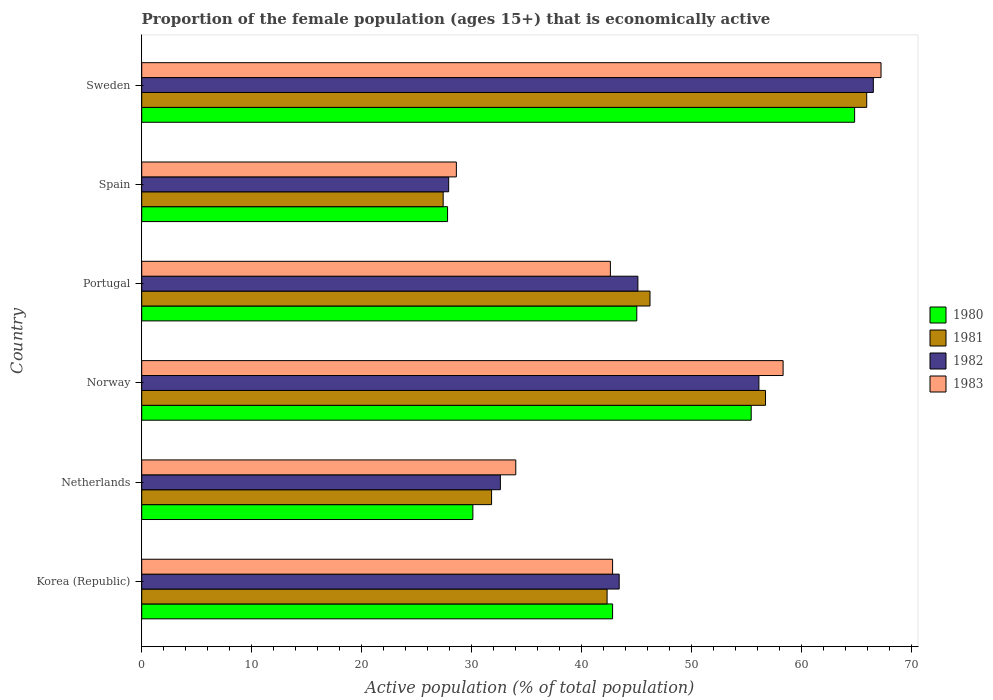Are the number of bars per tick equal to the number of legend labels?
Offer a terse response. Yes. Are the number of bars on each tick of the Y-axis equal?
Offer a terse response. Yes. What is the label of the 3rd group of bars from the top?
Offer a very short reply. Portugal. In how many cases, is the number of bars for a given country not equal to the number of legend labels?
Give a very brief answer. 0. What is the proportion of the female population that is economically active in 1982 in Sweden?
Keep it short and to the point. 66.5. Across all countries, what is the maximum proportion of the female population that is economically active in 1983?
Keep it short and to the point. 67.2. Across all countries, what is the minimum proportion of the female population that is economically active in 1982?
Offer a very short reply. 27.9. In which country was the proportion of the female population that is economically active in 1981 minimum?
Give a very brief answer. Spain. What is the total proportion of the female population that is economically active in 1980 in the graph?
Provide a short and direct response. 265.9. What is the difference between the proportion of the female population that is economically active in 1983 in Portugal and that in Spain?
Offer a very short reply. 14. What is the difference between the proportion of the female population that is economically active in 1981 in Portugal and the proportion of the female population that is economically active in 1980 in Netherlands?
Offer a terse response. 16.1. What is the average proportion of the female population that is economically active in 1983 per country?
Give a very brief answer. 45.58. What is the difference between the proportion of the female population that is economically active in 1982 and proportion of the female population that is economically active in 1983 in Netherlands?
Provide a short and direct response. -1.4. In how many countries, is the proportion of the female population that is economically active in 1982 greater than 52 %?
Ensure brevity in your answer.  2. What is the ratio of the proportion of the female population that is economically active in 1980 in Korea (Republic) to that in Spain?
Provide a short and direct response. 1.54. Is the proportion of the female population that is economically active in 1980 in Spain less than that in Sweden?
Make the answer very short. Yes. What is the difference between the highest and the second highest proportion of the female population that is economically active in 1980?
Provide a succinct answer. 9.4. What is the difference between the highest and the lowest proportion of the female population that is economically active in 1980?
Keep it short and to the point. 37. In how many countries, is the proportion of the female population that is economically active in 1982 greater than the average proportion of the female population that is economically active in 1982 taken over all countries?
Keep it short and to the point. 2. What does the 3rd bar from the bottom in Korea (Republic) represents?
Give a very brief answer. 1982. Is it the case that in every country, the sum of the proportion of the female population that is economically active in 1983 and proportion of the female population that is economically active in 1982 is greater than the proportion of the female population that is economically active in 1980?
Offer a very short reply. Yes. Are all the bars in the graph horizontal?
Make the answer very short. Yes. Where does the legend appear in the graph?
Your answer should be compact. Center right. How are the legend labels stacked?
Make the answer very short. Vertical. What is the title of the graph?
Ensure brevity in your answer.  Proportion of the female population (ages 15+) that is economically active. What is the label or title of the X-axis?
Your response must be concise. Active population (% of total population). What is the label or title of the Y-axis?
Ensure brevity in your answer.  Country. What is the Active population (% of total population) in 1980 in Korea (Republic)?
Provide a succinct answer. 42.8. What is the Active population (% of total population) in 1981 in Korea (Republic)?
Give a very brief answer. 42.3. What is the Active population (% of total population) in 1982 in Korea (Republic)?
Make the answer very short. 43.4. What is the Active population (% of total population) in 1983 in Korea (Republic)?
Provide a short and direct response. 42.8. What is the Active population (% of total population) of 1980 in Netherlands?
Give a very brief answer. 30.1. What is the Active population (% of total population) of 1981 in Netherlands?
Offer a very short reply. 31.8. What is the Active population (% of total population) of 1982 in Netherlands?
Keep it short and to the point. 32.6. What is the Active population (% of total population) in 1983 in Netherlands?
Your answer should be very brief. 34. What is the Active population (% of total population) in 1980 in Norway?
Your response must be concise. 55.4. What is the Active population (% of total population) of 1981 in Norway?
Give a very brief answer. 56.7. What is the Active population (% of total population) in 1982 in Norway?
Keep it short and to the point. 56.1. What is the Active population (% of total population) of 1983 in Norway?
Offer a very short reply. 58.3. What is the Active population (% of total population) in 1980 in Portugal?
Your answer should be compact. 45. What is the Active population (% of total population) of 1981 in Portugal?
Keep it short and to the point. 46.2. What is the Active population (% of total population) in 1982 in Portugal?
Your answer should be compact. 45.1. What is the Active population (% of total population) in 1983 in Portugal?
Give a very brief answer. 42.6. What is the Active population (% of total population) in 1980 in Spain?
Offer a terse response. 27.8. What is the Active population (% of total population) in 1981 in Spain?
Your response must be concise. 27.4. What is the Active population (% of total population) of 1982 in Spain?
Offer a very short reply. 27.9. What is the Active population (% of total population) of 1983 in Spain?
Your response must be concise. 28.6. What is the Active population (% of total population) of 1980 in Sweden?
Your answer should be very brief. 64.8. What is the Active population (% of total population) of 1981 in Sweden?
Your answer should be compact. 65.9. What is the Active population (% of total population) of 1982 in Sweden?
Make the answer very short. 66.5. What is the Active population (% of total population) of 1983 in Sweden?
Ensure brevity in your answer.  67.2. Across all countries, what is the maximum Active population (% of total population) in 1980?
Keep it short and to the point. 64.8. Across all countries, what is the maximum Active population (% of total population) of 1981?
Keep it short and to the point. 65.9. Across all countries, what is the maximum Active population (% of total population) of 1982?
Your answer should be compact. 66.5. Across all countries, what is the maximum Active population (% of total population) of 1983?
Offer a very short reply. 67.2. Across all countries, what is the minimum Active population (% of total population) in 1980?
Your answer should be very brief. 27.8. Across all countries, what is the minimum Active population (% of total population) in 1981?
Make the answer very short. 27.4. Across all countries, what is the minimum Active population (% of total population) in 1982?
Keep it short and to the point. 27.9. Across all countries, what is the minimum Active population (% of total population) of 1983?
Keep it short and to the point. 28.6. What is the total Active population (% of total population) of 1980 in the graph?
Your answer should be very brief. 265.9. What is the total Active population (% of total population) of 1981 in the graph?
Ensure brevity in your answer.  270.3. What is the total Active population (% of total population) of 1982 in the graph?
Offer a very short reply. 271.6. What is the total Active population (% of total population) in 1983 in the graph?
Your response must be concise. 273.5. What is the difference between the Active population (% of total population) of 1980 in Korea (Republic) and that in Netherlands?
Offer a terse response. 12.7. What is the difference between the Active population (% of total population) of 1981 in Korea (Republic) and that in Netherlands?
Offer a terse response. 10.5. What is the difference between the Active population (% of total population) of 1983 in Korea (Republic) and that in Netherlands?
Ensure brevity in your answer.  8.8. What is the difference between the Active population (% of total population) of 1980 in Korea (Republic) and that in Norway?
Ensure brevity in your answer.  -12.6. What is the difference between the Active population (% of total population) in 1981 in Korea (Republic) and that in Norway?
Give a very brief answer. -14.4. What is the difference between the Active population (% of total population) in 1982 in Korea (Republic) and that in Norway?
Provide a short and direct response. -12.7. What is the difference between the Active population (% of total population) in 1983 in Korea (Republic) and that in Norway?
Provide a short and direct response. -15.5. What is the difference between the Active population (% of total population) of 1980 in Korea (Republic) and that in Portugal?
Offer a terse response. -2.2. What is the difference between the Active population (% of total population) in 1982 in Korea (Republic) and that in Portugal?
Offer a terse response. -1.7. What is the difference between the Active population (% of total population) of 1981 in Korea (Republic) and that in Sweden?
Ensure brevity in your answer.  -23.6. What is the difference between the Active population (% of total population) in 1982 in Korea (Republic) and that in Sweden?
Offer a very short reply. -23.1. What is the difference between the Active population (% of total population) of 1983 in Korea (Republic) and that in Sweden?
Your response must be concise. -24.4. What is the difference between the Active population (% of total population) of 1980 in Netherlands and that in Norway?
Provide a short and direct response. -25.3. What is the difference between the Active population (% of total population) in 1981 in Netherlands and that in Norway?
Your answer should be very brief. -24.9. What is the difference between the Active population (% of total population) of 1982 in Netherlands and that in Norway?
Make the answer very short. -23.5. What is the difference between the Active population (% of total population) in 1983 in Netherlands and that in Norway?
Provide a succinct answer. -24.3. What is the difference between the Active population (% of total population) of 1980 in Netherlands and that in Portugal?
Your response must be concise. -14.9. What is the difference between the Active population (% of total population) of 1981 in Netherlands and that in Portugal?
Provide a short and direct response. -14.4. What is the difference between the Active population (% of total population) in 1983 in Netherlands and that in Spain?
Your answer should be compact. 5.4. What is the difference between the Active population (% of total population) of 1980 in Netherlands and that in Sweden?
Offer a terse response. -34.7. What is the difference between the Active population (% of total population) of 1981 in Netherlands and that in Sweden?
Provide a short and direct response. -34.1. What is the difference between the Active population (% of total population) of 1982 in Netherlands and that in Sweden?
Make the answer very short. -33.9. What is the difference between the Active population (% of total population) in 1983 in Netherlands and that in Sweden?
Ensure brevity in your answer.  -33.2. What is the difference between the Active population (% of total population) in 1981 in Norway and that in Portugal?
Offer a terse response. 10.5. What is the difference between the Active population (% of total population) in 1982 in Norway and that in Portugal?
Provide a succinct answer. 11. What is the difference between the Active population (% of total population) in 1980 in Norway and that in Spain?
Your answer should be compact. 27.6. What is the difference between the Active population (% of total population) of 1981 in Norway and that in Spain?
Your response must be concise. 29.3. What is the difference between the Active population (% of total population) of 1982 in Norway and that in Spain?
Your response must be concise. 28.2. What is the difference between the Active population (% of total population) of 1983 in Norway and that in Spain?
Make the answer very short. 29.7. What is the difference between the Active population (% of total population) of 1983 in Norway and that in Sweden?
Keep it short and to the point. -8.9. What is the difference between the Active population (% of total population) in 1980 in Portugal and that in Spain?
Your answer should be very brief. 17.2. What is the difference between the Active population (% of total population) of 1981 in Portugal and that in Spain?
Your answer should be compact. 18.8. What is the difference between the Active population (% of total population) of 1982 in Portugal and that in Spain?
Offer a very short reply. 17.2. What is the difference between the Active population (% of total population) of 1980 in Portugal and that in Sweden?
Provide a short and direct response. -19.8. What is the difference between the Active population (% of total population) in 1981 in Portugal and that in Sweden?
Keep it short and to the point. -19.7. What is the difference between the Active population (% of total population) of 1982 in Portugal and that in Sweden?
Ensure brevity in your answer.  -21.4. What is the difference between the Active population (% of total population) of 1983 in Portugal and that in Sweden?
Your answer should be very brief. -24.6. What is the difference between the Active population (% of total population) of 1980 in Spain and that in Sweden?
Your answer should be compact. -37. What is the difference between the Active population (% of total population) in 1981 in Spain and that in Sweden?
Provide a succinct answer. -38.5. What is the difference between the Active population (% of total population) of 1982 in Spain and that in Sweden?
Offer a very short reply. -38.6. What is the difference between the Active population (% of total population) in 1983 in Spain and that in Sweden?
Give a very brief answer. -38.6. What is the difference between the Active population (% of total population) in 1980 in Korea (Republic) and the Active population (% of total population) in 1981 in Netherlands?
Provide a short and direct response. 11. What is the difference between the Active population (% of total population) of 1980 in Korea (Republic) and the Active population (% of total population) of 1983 in Netherlands?
Give a very brief answer. 8.8. What is the difference between the Active population (% of total population) in 1981 in Korea (Republic) and the Active population (% of total population) in 1982 in Netherlands?
Provide a succinct answer. 9.7. What is the difference between the Active population (% of total population) in 1981 in Korea (Republic) and the Active population (% of total population) in 1983 in Netherlands?
Keep it short and to the point. 8.3. What is the difference between the Active population (% of total population) in 1982 in Korea (Republic) and the Active population (% of total population) in 1983 in Netherlands?
Give a very brief answer. 9.4. What is the difference between the Active population (% of total population) of 1980 in Korea (Republic) and the Active population (% of total population) of 1981 in Norway?
Your answer should be very brief. -13.9. What is the difference between the Active population (% of total population) in 1980 in Korea (Republic) and the Active population (% of total population) in 1982 in Norway?
Your answer should be compact. -13.3. What is the difference between the Active population (% of total population) in 1980 in Korea (Republic) and the Active population (% of total population) in 1983 in Norway?
Keep it short and to the point. -15.5. What is the difference between the Active population (% of total population) in 1981 in Korea (Republic) and the Active population (% of total population) in 1982 in Norway?
Provide a short and direct response. -13.8. What is the difference between the Active population (% of total population) in 1981 in Korea (Republic) and the Active population (% of total population) in 1983 in Norway?
Give a very brief answer. -16. What is the difference between the Active population (% of total population) in 1982 in Korea (Republic) and the Active population (% of total population) in 1983 in Norway?
Provide a succinct answer. -14.9. What is the difference between the Active population (% of total population) in 1980 in Korea (Republic) and the Active population (% of total population) in 1981 in Portugal?
Provide a short and direct response. -3.4. What is the difference between the Active population (% of total population) in 1980 in Korea (Republic) and the Active population (% of total population) in 1983 in Portugal?
Your answer should be very brief. 0.2. What is the difference between the Active population (% of total population) in 1982 in Korea (Republic) and the Active population (% of total population) in 1983 in Portugal?
Make the answer very short. 0.8. What is the difference between the Active population (% of total population) of 1980 in Korea (Republic) and the Active population (% of total population) of 1981 in Spain?
Your answer should be compact. 15.4. What is the difference between the Active population (% of total population) in 1980 in Korea (Republic) and the Active population (% of total population) in 1982 in Spain?
Offer a terse response. 14.9. What is the difference between the Active population (% of total population) of 1980 in Korea (Republic) and the Active population (% of total population) of 1983 in Spain?
Offer a very short reply. 14.2. What is the difference between the Active population (% of total population) of 1981 in Korea (Republic) and the Active population (% of total population) of 1983 in Spain?
Keep it short and to the point. 13.7. What is the difference between the Active population (% of total population) of 1980 in Korea (Republic) and the Active population (% of total population) of 1981 in Sweden?
Offer a very short reply. -23.1. What is the difference between the Active population (% of total population) in 1980 in Korea (Republic) and the Active population (% of total population) in 1982 in Sweden?
Give a very brief answer. -23.7. What is the difference between the Active population (% of total population) in 1980 in Korea (Republic) and the Active population (% of total population) in 1983 in Sweden?
Keep it short and to the point. -24.4. What is the difference between the Active population (% of total population) in 1981 in Korea (Republic) and the Active population (% of total population) in 1982 in Sweden?
Offer a terse response. -24.2. What is the difference between the Active population (% of total population) of 1981 in Korea (Republic) and the Active population (% of total population) of 1983 in Sweden?
Keep it short and to the point. -24.9. What is the difference between the Active population (% of total population) of 1982 in Korea (Republic) and the Active population (% of total population) of 1983 in Sweden?
Make the answer very short. -23.8. What is the difference between the Active population (% of total population) of 1980 in Netherlands and the Active population (% of total population) of 1981 in Norway?
Ensure brevity in your answer.  -26.6. What is the difference between the Active population (% of total population) in 1980 in Netherlands and the Active population (% of total population) in 1982 in Norway?
Keep it short and to the point. -26. What is the difference between the Active population (% of total population) in 1980 in Netherlands and the Active population (% of total population) in 1983 in Norway?
Your response must be concise. -28.2. What is the difference between the Active population (% of total population) in 1981 in Netherlands and the Active population (% of total population) in 1982 in Norway?
Offer a terse response. -24.3. What is the difference between the Active population (% of total population) of 1981 in Netherlands and the Active population (% of total population) of 1983 in Norway?
Your answer should be compact. -26.5. What is the difference between the Active population (% of total population) in 1982 in Netherlands and the Active population (% of total population) in 1983 in Norway?
Keep it short and to the point. -25.7. What is the difference between the Active population (% of total population) in 1980 in Netherlands and the Active population (% of total population) in 1981 in Portugal?
Your answer should be very brief. -16.1. What is the difference between the Active population (% of total population) of 1982 in Netherlands and the Active population (% of total population) of 1983 in Portugal?
Offer a very short reply. -10. What is the difference between the Active population (% of total population) of 1980 in Netherlands and the Active population (% of total population) of 1981 in Spain?
Ensure brevity in your answer.  2.7. What is the difference between the Active population (% of total population) of 1980 in Netherlands and the Active population (% of total population) of 1982 in Spain?
Offer a very short reply. 2.2. What is the difference between the Active population (% of total population) of 1980 in Netherlands and the Active population (% of total population) of 1983 in Spain?
Your response must be concise. 1.5. What is the difference between the Active population (% of total population) of 1981 in Netherlands and the Active population (% of total population) of 1982 in Spain?
Ensure brevity in your answer.  3.9. What is the difference between the Active population (% of total population) of 1981 in Netherlands and the Active population (% of total population) of 1983 in Spain?
Make the answer very short. 3.2. What is the difference between the Active population (% of total population) in 1980 in Netherlands and the Active population (% of total population) in 1981 in Sweden?
Provide a short and direct response. -35.8. What is the difference between the Active population (% of total population) of 1980 in Netherlands and the Active population (% of total population) of 1982 in Sweden?
Offer a terse response. -36.4. What is the difference between the Active population (% of total population) of 1980 in Netherlands and the Active population (% of total population) of 1983 in Sweden?
Offer a very short reply. -37.1. What is the difference between the Active population (% of total population) in 1981 in Netherlands and the Active population (% of total population) in 1982 in Sweden?
Your answer should be compact. -34.7. What is the difference between the Active population (% of total population) in 1981 in Netherlands and the Active population (% of total population) in 1983 in Sweden?
Keep it short and to the point. -35.4. What is the difference between the Active population (% of total population) of 1982 in Netherlands and the Active population (% of total population) of 1983 in Sweden?
Provide a short and direct response. -34.6. What is the difference between the Active population (% of total population) of 1980 in Norway and the Active population (% of total population) of 1981 in Portugal?
Offer a very short reply. 9.2. What is the difference between the Active population (% of total population) of 1980 in Norway and the Active population (% of total population) of 1983 in Portugal?
Offer a very short reply. 12.8. What is the difference between the Active population (% of total population) in 1980 in Norway and the Active population (% of total population) in 1983 in Spain?
Make the answer very short. 26.8. What is the difference between the Active population (% of total population) of 1981 in Norway and the Active population (% of total population) of 1982 in Spain?
Provide a succinct answer. 28.8. What is the difference between the Active population (% of total population) in 1981 in Norway and the Active population (% of total population) in 1983 in Spain?
Your response must be concise. 28.1. What is the difference between the Active population (% of total population) of 1980 in Norway and the Active population (% of total population) of 1983 in Sweden?
Make the answer very short. -11.8. What is the difference between the Active population (% of total population) in 1981 in Norway and the Active population (% of total population) in 1982 in Sweden?
Your answer should be very brief. -9.8. What is the difference between the Active population (% of total population) in 1980 in Portugal and the Active population (% of total population) in 1981 in Spain?
Your response must be concise. 17.6. What is the difference between the Active population (% of total population) in 1981 in Portugal and the Active population (% of total population) in 1982 in Spain?
Provide a short and direct response. 18.3. What is the difference between the Active population (% of total population) of 1982 in Portugal and the Active population (% of total population) of 1983 in Spain?
Your answer should be very brief. 16.5. What is the difference between the Active population (% of total population) in 1980 in Portugal and the Active population (% of total population) in 1981 in Sweden?
Keep it short and to the point. -20.9. What is the difference between the Active population (% of total population) in 1980 in Portugal and the Active population (% of total population) in 1982 in Sweden?
Give a very brief answer. -21.5. What is the difference between the Active population (% of total population) in 1980 in Portugal and the Active population (% of total population) in 1983 in Sweden?
Ensure brevity in your answer.  -22.2. What is the difference between the Active population (% of total population) of 1981 in Portugal and the Active population (% of total population) of 1982 in Sweden?
Offer a terse response. -20.3. What is the difference between the Active population (% of total population) of 1981 in Portugal and the Active population (% of total population) of 1983 in Sweden?
Offer a terse response. -21. What is the difference between the Active population (% of total population) in 1982 in Portugal and the Active population (% of total population) in 1983 in Sweden?
Ensure brevity in your answer.  -22.1. What is the difference between the Active population (% of total population) of 1980 in Spain and the Active population (% of total population) of 1981 in Sweden?
Make the answer very short. -38.1. What is the difference between the Active population (% of total population) in 1980 in Spain and the Active population (% of total population) in 1982 in Sweden?
Your response must be concise. -38.7. What is the difference between the Active population (% of total population) in 1980 in Spain and the Active population (% of total population) in 1983 in Sweden?
Give a very brief answer. -39.4. What is the difference between the Active population (% of total population) in 1981 in Spain and the Active population (% of total population) in 1982 in Sweden?
Your response must be concise. -39.1. What is the difference between the Active population (% of total population) of 1981 in Spain and the Active population (% of total population) of 1983 in Sweden?
Provide a short and direct response. -39.8. What is the difference between the Active population (% of total population) in 1982 in Spain and the Active population (% of total population) in 1983 in Sweden?
Ensure brevity in your answer.  -39.3. What is the average Active population (% of total population) of 1980 per country?
Give a very brief answer. 44.32. What is the average Active population (% of total population) of 1981 per country?
Give a very brief answer. 45.05. What is the average Active population (% of total population) of 1982 per country?
Offer a terse response. 45.27. What is the average Active population (% of total population) of 1983 per country?
Offer a terse response. 45.58. What is the difference between the Active population (% of total population) of 1980 and Active population (% of total population) of 1982 in Korea (Republic)?
Give a very brief answer. -0.6. What is the difference between the Active population (% of total population) in 1980 and Active population (% of total population) in 1983 in Korea (Republic)?
Give a very brief answer. 0. What is the difference between the Active population (% of total population) in 1981 and Active population (% of total population) in 1982 in Netherlands?
Your response must be concise. -0.8. What is the difference between the Active population (% of total population) in 1982 and Active population (% of total population) in 1983 in Netherlands?
Ensure brevity in your answer.  -1.4. What is the difference between the Active population (% of total population) of 1980 and Active population (% of total population) of 1983 in Norway?
Your response must be concise. -2.9. What is the difference between the Active population (% of total population) of 1981 and Active population (% of total population) of 1983 in Norway?
Your answer should be very brief. -1.6. What is the difference between the Active population (% of total population) in 1982 and Active population (% of total population) in 1983 in Norway?
Your answer should be compact. -2.2. What is the difference between the Active population (% of total population) in 1980 and Active population (% of total population) in 1982 in Portugal?
Make the answer very short. -0.1. What is the difference between the Active population (% of total population) in 1981 and Active population (% of total population) in 1982 in Portugal?
Provide a succinct answer. 1.1. What is the difference between the Active population (% of total population) of 1982 and Active population (% of total population) of 1983 in Portugal?
Give a very brief answer. 2.5. What is the difference between the Active population (% of total population) of 1980 and Active population (% of total population) of 1982 in Spain?
Offer a terse response. -0.1. What is the difference between the Active population (% of total population) in 1980 and Active population (% of total population) in 1983 in Spain?
Ensure brevity in your answer.  -0.8. What is the difference between the Active population (% of total population) of 1981 and Active population (% of total population) of 1983 in Spain?
Offer a terse response. -1.2. What is the difference between the Active population (% of total population) in 1980 and Active population (% of total population) in 1982 in Sweden?
Offer a very short reply. -1.7. What is the difference between the Active population (% of total population) of 1981 and Active population (% of total population) of 1982 in Sweden?
Offer a very short reply. -0.6. What is the difference between the Active population (% of total population) of 1982 and Active population (% of total population) of 1983 in Sweden?
Your answer should be very brief. -0.7. What is the ratio of the Active population (% of total population) of 1980 in Korea (Republic) to that in Netherlands?
Provide a succinct answer. 1.42. What is the ratio of the Active population (% of total population) of 1981 in Korea (Republic) to that in Netherlands?
Your answer should be compact. 1.33. What is the ratio of the Active population (% of total population) of 1982 in Korea (Republic) to that in Netherlands?
Provide a short and direct response. 1.33. What is the ratio of the Active population (% of total population) in 1983 in Korea (Republic) to that in Netherlands?
Make the answer very short. 1.26. What is the ratio of the Active population (% of total population) in 1980 in Korea (Republic) to that in Norway?
Offer a very short reply. 0.77. What is the ratio of the Active population (% of total population) of 1981 in Korea (Republic) to that in Norway?
Offer a very short reply. 0.75. What is the ratio of the Active population (% of total population) in 1982 in Korea (Republic) to that in Norway?
Your answer should be very brief. 0.77. What is the ratio of the Active population (% of total population) in 1983 in Korea (Republic) to that in Norway?
Your answer should be compact. 0.73. What is the ratio of the Active population (% of total population) in 1980 in Korea (Republic) to that in Portugal?
Provide a succinct answer. 0.95. What is the ratio of the Active population (% of total population) of 1981 in Korea (Republic) to that in Portugal?
Your answer should be very brief. 0.92. What is the ratio of the Active population (% of total population) of 1982 in Korea (Republic) to that in Portugal?
Your answer should be compact. 0.96. What is the ratio of the Active population (% of total population) of 1980 in Korea (Republic) to that in Spain?
Make the answer very short. 1.54. What is the ratio of the Active population (% of total population) in 1981 in Korea (Republic) to that in Spain?
Your answer should be compact. 1.54. What is the ratio of the Active population (% of total population) in 1982 in Korea (Republic) to that in Spain?
Give a very brief answer. 1.56. What is the ratio of the Active population (% of total population) of 1983 in Korea (Republic) to that in Spain?
Give a very brief answer. 1.5. What is the ratio of the Active population (% of total population) in 1980 in Korea (Republic) to that in Sweden?
Your answer should be compact. 0.66. What is the ratio of the Active population (% of total population) of 1981 in Korea (Republic) to that in Sweden?
Offer a very short reply. 0.64. What is the ratio of the Active population (% of total population) of 1982 in Korea (Republic) to that in Sweden?
Provide a succinct answer. 0.65. What is the ratio of the Active population (% of total population) in 1983 in Korea (Republic) to that in Sweden?
Ensure brevity in your answer.  0.64. What is the ratio of the Active population (% of total population) in 1980 in Netherlands to that in Norway?
Your response must be concise. 0.54. What is the ratio of the Active population (% of total population) of 1981 in Netherlands to that in Norway?
Give a very brief answer. 0.56. What is the ratio of the Active population (% of total population) of 1982 in Netherlands to that in Norway?
Make the answer very short. 0.58. What is the ratio of the Active population (% of total population) in 1983 in Netherlands to that in Norway?
Offer a terse response. 0.58. What is the ratio of the Active population (% of total population) in 1980 in Netherlands to that in Portugal?
Your answer should be compact. 0.67. What is the ratio of the Active population (% of total population) in 1981 in Netherlands to that in Portugal?
Your response must be concise. 0.69. What is the ratio of the Active population (% of total population) of 1982 in Netherlands to that in Portugal?
Make the answer very short. 0.72. What is the ratio of the Active population (% of total population) in 1983 in Netherlands to that in Portugal?
Keep it short and to the point. 0.8. What is the ratio of the Active population (% of total population) in 1980 in Netherlands to that in Spain?
Your answer should be very brief. 1.08. What is the ratio of the Active population (% of total population) of 1981 in Netherlands to that in Spain?
Offer a terse response. 1.16. What is the ratio of the Active population (% of total population) of 1982 in Netherlands to that in Spain?
Provide a short and direct response. 1.17. What is the ratio of the Active population (% of total population) of 1983 in Netherlands to that in Spain?
Your answer should be compact. 1.19. What is the ratio of the Active population (% of total population) in 1980 in Netherlands to that in Sweden?
Your answer should be very brief. 0.46. What is the ratio of the Active population (% of total population) in 1981 in Netherlands to that in Sweden?
Offer a very short reply. 0.48. What is the ratio of the Active population (% of total population) of 1982 in Netherlands to that in Sweden?
Provide a succinct answer. 0.49. What is the ratio of the Active population (% of total population) in 1983 in Netherlands to that in Sweden?
Provide a short and direct response. 0.51. What is the ratio of the Active population (% of total population) in 1980 in Norway to that in Portugal?
Offer a very short reply. 1.23. What is the ratio of the Active population (% of total population) in 1981 in Norway to that in Portugal?
Make the answer very short. 1.23. What is the ratio of the Active population (% of total population) in 1982 in Norway to that in Portugal?
Provide a short and direct response. 1.24. What is the ratio of the Active population (% of total population) of 1983 in Norway to that in Portugal?
Offer a terse response. 1.37. What is the ratio of the Active population (% of total population) in 1980 in Norway to that in Spain?
Provide a short and direct response. 1.99. What is the ratio of the Active population (% of total population) in 1981 in Norway to that in Spain?
Make the answer very short. 2.07. What is the ratio of the Active population (% of total population) of 1982 in Norway to that in Spain?
Your answer should be very brief. 2.01. What is the ratio of the Active population (% of total population) in 1983 in Norway to that in Spain?
Offer a very short reply. 2.04. What is the ratio of the Active population (% of total population) of 1980 in Norway to that in Sweden?
Keep it short and to the point. 0.85. What is the ratio of the Active population (% of total population) of 1981 in Norway to that in Sweden?
Offer a very short reply. 0.86. What is the ratio of the Active population (% of total population) of 1982 in Norway to that in Sweden?
Give a very brief answer. 0.84. What is the ratio of the Active population (% of total population) of 1983 in Norway to that in Sweden?
Give a very brief answer. 0.87. What is the ratio of the Active population (% of total population) of 1980 in Portugal to that in Spain?
Offer a terse response. 1.62. What is the ratio of the Active population (% of total population) of 1981 in Portugal to that in Spain?
Make the answer very short. 1.69. What is the ratio of the Active population (% of total population) in 1982 in Portugal to that in Spain?
Offer a very short reply. 1.62. What is the ratio of the Active population (% of total population) of 1983 in Portugal to that in Spain?
Keep it short and to the point. 1.49. What is the ratio of the Active population (% of total population) in 1980 in Portugal to that in Sweden?
Keep it short and to the point. 0.69. What is the ratio of the Active population (% of total population) of 1981 in Portugal to that in Sweden?
Keep it short and to the point. 0.7. What is the ratio of the Active population (% of total population) in 1982 in Portugal to that in Sweden?
Your answer should be compact. 0.68. What is the ratio of the Active population (% of total population) in 1983 in Portugal to that in Sweden?
Your answer should be very brief. 0.63. What is the ratio of the Active population (% of total population) of 1980 in Spain to that in Sweden?
Your answer should be compact. 0.43. What is the ratio of the Active population (% of total population) of 1981 in Spain to that in Sweden?
Keep it short and to the point. 0.42. What is the ratio of the Active population (% of total population) of 1982 in Spain to that in Sweden?
Your response must be concise. 0.42. What is the ratio of the Active population (% of total population) of 1983 in Spain to that in Sweden?
Your answer should be very brief. 0.43. What is the difference between the highest and the second highest Active population (% of total population) of 1980?
Your response must be concise. 9.4. What is the difference between the highest and the second highest Active population (% of total population) in 1981?
Your answer should be very brief. 9.2. What is the difference between the highest and the second highest Active population (% of total population) in 1982?
Provide a short and direct response. 10.4. What is the difference between the highest and the second highest Active population (% of total population) in 1983?
Your response must be concise. 8.9. What is the difference between the highest and the lowest Active population (% of total population) in 1980?
Provide a short and direct response. 37. What is the difference between the highest and the lowest Active population (% of total population) in 1981?
Give a very brief answer. 38.5. What is the difference between the highest and the lowest Active population (% of total population) in 1982?
Your answer should be compact. 38.6. What is the difference between the highest and the lowest Active population (% of total population) in 1983?
Your answer should be very brief. 38.6. 